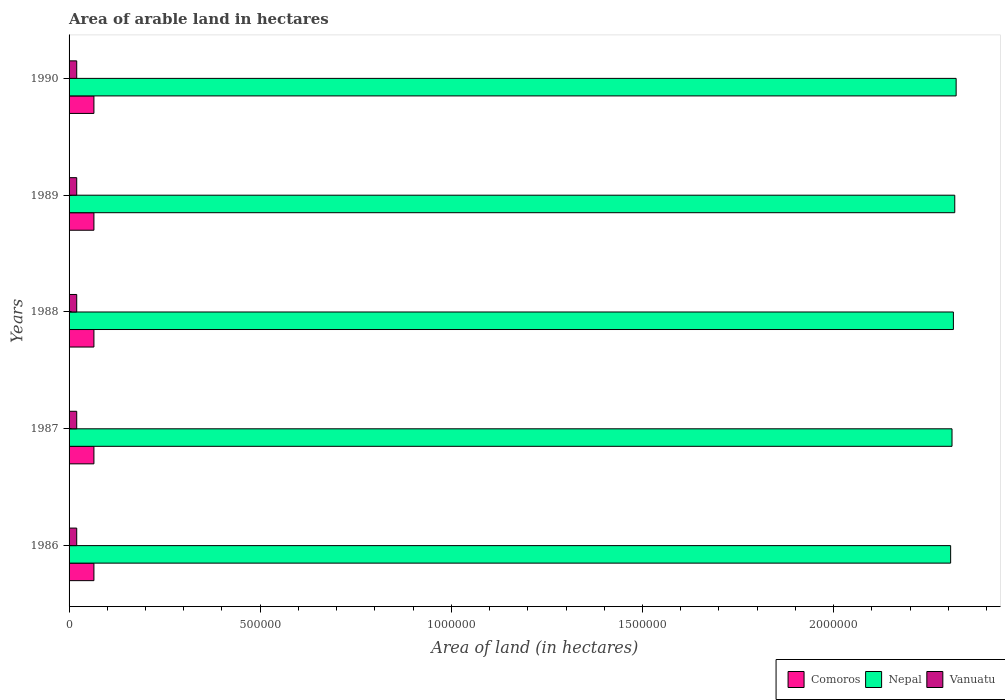How many groups of bars are there?
Your answer should be compact. 5. Are the number of bars per tick equal to the number of legend labels?
Provide a short and direct response. Yes. Are the number of bars on each tick of the Y-axis equal?
Offer a very short reply. Yes. How many bars are there on the 1st tick from the bottom?
Your response must be concise. 3. What is the total arable land in Comoros in 1988?
Your response must be concise. 6.50e+04. Across all years, what is the maximum total arable land in Vanuatu?
Give a very brief answer. 2.00e+04. Across all years, what is the minimum total arable land in Vanuatu?
Provide a succinct answer. 2.00e+04. In which year was the total arable land in Comoros maximum?
Provide a succinct answer. 1986. In which year was the total arable land in Nepal minimum?
Your response must be concise. 1986. What is the total total arable land in Vanuatu in the graph?
Your answer should be very brief. 1.00e+05. What is the difference between the total arable land in Comoros in 1986 and that in 1989?
Offer a very short reply. 0. What is the difference between the total arable land in Nepal in 1987 and the total arable land in Vanuatu in 1988?
Provide a short and direct response. 2.29e+06. What is the average total arable land in Comoros per year?
Keep it short and to the point. 6.50e+04. In the year 1986, what is the difference between the total arable land in Comoros and total arable land in Vanuatu?
Give a very brief answer. 4.50e+04. In how many years, is the total arable land in Nepal greater than 400000 hectares?
Offer a very short reply. 5. What is the ratio of the total arable land in Nepal in 1987 to that in 1989?
Make the answer very short. 1. What is the difference between the highest and the second highest total arable land in Comoros?
Keep it short and to the point. 0. What is the difference between the highest and the lowest total arable land in Nepal?
Provide a short and direct response. 1.44e+04. In how many years, is the total arable land in Vanuatu greater than the average total arable land in Vanuatu taken over all years?
Your response must be concise. 0. What does the 2nd bar from the top in 1990 represents?
Give a very brief answer. Nepal. What does the 2nd bar from the bottom in 1988 represents?
Your response must be concise. Nepal. How many bars are there?
Keep it short and to the point. 15. What is the difference between two consecutive major ticks on the X-axis?
Your answer should be compact. 5.00e+05. Are the values on the major ticks of X-axis written in scientific E-notation?
Your answer should be compact. No. Does the graph contain grids?
Provide a succinct answer. No. Where does the legend appear in the graph?
Make the answer very short. Bottom right. What is the title of the graph?
Your response must be concise. Area of arable land in hectares. Does "United Kingdom" appear as one of the legend labels in the graph?
Ensure brevity in your answer.  No. What is the label or title of the X-axis?
Your answer should be compact. Area of land (in hectares). What is the label or title of the Y-axis?
Make the answer very short. Years. What is the Area of land (in hectares) of Comoros in 1986?
Offer a terse response. 6.50e+04. What is the Area of land (in hectares) of Nepal in 1986?
Your answer should be compact. 2.31e+06. What is the Area of land (in hectares) of Vanuatu in 1986?
Make the answer very short. 2.00e+04. What is the Area of land (in hectares) in Comoros in 1987?
Keep it short and to the point. 6.50e+04. What is the Area of land (in hectares) in Nepal in 1987?
Provide a short and direct response. 2.31e+06. What is the Area of land (in hectares) in Comoros in 1988?
Offer a terse response. 6.50e+04. What is the Area of land (in hectares) in Nepal in 1988?
Your answer should be very brief. 2.31e+06. What is the Area of land (in hectares) in Comoros in 1989?
Provide a succinct answer. 6.50e+04. What is the Area of land (in hectares) of Nepal in 1989?
Your response must be concise. 2.32e+06. What is the Area of land (in hectares) in Vanuatu in 1989?
Your response must be concise. 2.00e+04. What is the Area of land (in hectares) of Comoros in 1990?
Ensure brevity in your answer.  6.50e+04. What is the Area of land (in hectares) in Nepal in 1990?
Your answer should be very brief. 2.32e+06. What is the Area of land (in hectares) of Vanuatu in 1990?
Ensure brevity in your answer.  2.00e+04. Across all years, what is the maximum Area of land (in hectares) of Comoros?
Make the answer very short. 6.50e+04. Across all years, what is the maximum Area of land (in hectares) in Nepal?
Keep it short and to the point. 2.32e+06. Across all years, what is the maximum Area of land (in hectares) of Vanuatu?
Make the answer very short. 2.00e+04. Across all years, what is the minimum Area of land (in hectares) in Comoros?
Keep it short and to the point. 6.50e+04. Across all years, what is the minimum Area of land (in hectares) in Nepal?
Provide a succinct answer. 2.31e+06. What is the total Area of land (in hectares) of Comoros in the graph?
Offer a terse response. 3.25e+05. What is the total Area of land (in hectares) in Nepal in the graph?
Offer a terse response. 1.16e+07. What is the difference between the Area of land (in hectares) in Comoros in 1986 and that in 1987?
Keep it short and to the point. 0. What is the difference between the Area of land (in hectares) in Nepal in 1986 and that in 1987?
Ensure brevity in your answer.  -3600. What is the difference between the Area of land (in hectares) in Nepal in 1986 and that in 1988?
Provide a short and direct response. -7200. What is the difference between the Area of land (in hectares) in Vanuatu in 1986 and that in 1988?
Offer a very short reply. 0. What is the difference between the Area of land (in hectares) of Comoros in 1986 and that in 1989?
Keep it short and to the point. 0. What is the difference between the Area of land (in hectares) in Nepal in 1986 and that in 1989?
Ensure brevity in your answer.  -1.08e+04. What is the difference between the Area of land (in hectares) of Vanuatu in 1986 and that in 1989?
Provide a succinct answer. 0. What is the difference between the Area of land (in hectares) in Nepal in 1986 and that in 1990?
Give a very brief answer. -1.44e+04. What is the difference between the Area of land (in hectares) in Nepal in 1987 and that in 1988?
Ensure brevity in your answer.  -3600. What is the difference between the Area of land (in hectares) of Vanuatu in 1987 and that in 1988?
Your response must be concise. 0. What is the difference between the Area of land (in hectares) in Nepal in 1987 and that in 1989?
Your response must be concise. -7200. What is the difference between the Area of land (in hectares) of Vanuatu in 1987 and that in 1989?
Offer a terse response. 0. What is the difference between the Area of land (in hectares) in Comoros in 1987 and that in 1990?
Provide a succinct answer. 0. What is the difference between the Area of land (in hectares) in Nepal in 1987 and that in 1990?
Offer a terse response. -1.08e+04. What is the difference between the Area of land (in hectares) of Nepal in 1988 and that in 1989?
Your answer should be compact. -3600. What is the difference between the Area of land (in hectares) of Vanuatu in 1988 and that in 1989?
Offer a very short reply. 0. What is the difference between the Area of land (in hectares) in Comoros in 1988 and that in 1990?
Ensure brevity in your answer.  0. What is the difference between the Area of land (in hectares) of Nepal in 1988 and that in 1990?
Ensure brevity in your answer.  -7200. What is the difference between the Area of land (in hectares) in Vanuatu in 1988 and that in 1990?
Keep it short and to the point. 0. What is the difference between the Area of land (in hectares) in Comoros in 1989 and that in 1990?
Your answer should be very brief. 0. What is the difference between the Area of land (in hectares) of Nepal in 1989 and that in 1990?
Make the answer very short. -3600. What is the difference between the Area of land (in hectares) in Vanuatu in 1989 and that in 1990?
Offer a terse response. 0. What is the difference between the Area of land (in hectares) in Comoros in 1986 and the Area of land (in hectares) in Nepal in 1987?
Make the answer very short. -2.24e+06. What is the difference between the Area of land (in hectares) of Comoros in 1986 and the Area of land (in hectares) of Vanuatu in 1987?
Provide a succinct answer. 4.50e+04. What is the difference between the Area of land (in hectares) of Nepal in 1986 and the Area of land (in hectares) of Vanuatu in 1987?
Offer a very short reply. 2.29e+06. What is the difference between the Area of land (in hectares) of Comoros in 1986 and the Area of land (in hectares) of Nepal in 1988?
Your response must be concise. -2.25e+06. What is the difference between the Area of land (in hectares) in Comoros in 1986 and the Area of land (in hectares) in Vanuatu in 1988?
Keep it short and to the point. 4.50e+04. What is the difference between the Area of land (in hectares) of Nepal in 1986 and the Area of land (in hectares) of Vanuatu in 1988?
Make the answer very short. 2.29e+06. What is the difference between the Area of land (in hectares) of Comoros in 1986 and the Area of land (in hectares) of Nepal in 1989?
Your answer should be very brief. -2.25e+06. What is the difference between the Area of land (in hectares) of Comoros in 1986 and the Area of land (in hectares) of Vanuatu in 1989?
Your answer should be very brief. 4.50e+04. What is the difference between the Area of land (in hectares) in Nepal in 1986 and the Area of land (in hectares) in Vanuatu in 1989?
Your answer should be compact. 2.29e+06. What is the difference between the Area of land (in hectares) of Comoros in 1986 and the Area of land (in hectares) of Nepal in 1990?
Offer a terse response. -2.26e+06. What is the difference between the Area of land (in hectares) of Comoros in 1986 and the Area of land (in hectares) of Vanuatu in 1990?
Keep it short and to the point. 4.50e+04. What is the difference between the Area of land (in hectares) of Nepal in 1986 and the Area of land (in hectares) of Vanuatu in 1990?
Give a very brief answer. 2.29e+06. What is the difference between the Area of land (in hectares) in Comoros in 1987 and the Area of land (in hectares) in Nepal in 1988?
Your answer should be very brief. -2.25e+06. What is the difference between the Area of land (in hectares) in Comoros in 1987 and the Area of land (in hectares) in Vanuatu in 1988?
Make the answer very short. 4.50e+04. What is the difference between the Area of land (in hectares) of Nepal in 1987 and the Area of land (in hectares) of Vanuatu in 1988?
Your answer should be very brief. 2.29e+06. What is the difference between the Area of land (in hectares) of Comoros in 1987 and the Area of land (in hectares) of Nepal in 1989?
Offer a terse response. -2.25e+06. What is the difference between the Area of land (in hectares) of Comoros in 1987 and the Area of land (in hectares) of Vanuatu in 1989?
Your answer should be compact. 4.50e+04. What is the difference between the Area of land (in hectares) in Nepal in 1987 and the Area of land (in hectares) in Vanuatu in 1989?
Keep it short and to the point. 2.29e+06. What is the difference between the Area of land (in hectares) in Comoros in 1987 and the Area of land (in hectares) in Nepal in 1990?
Offer a terse response. -2.26e+06. What is the difference between the Area of land (in hectares) of Comoros in 1987 and the Area of land (in hectares) of Vanuatu in 1990?
Give a very brief answer. 4.50e+04. What is the difference between the Area of land (in hectares) in Nepal in 1987 and the Area of land (in hectares) in Vanuatu in 1990?
Your response must be concise. 2.29e+06. What is the difference between the Area of land (in hectares) in Comoros in 1988 and the Area of land (in hectares) in Nepal in 1989?
Your answer should be compact. -2.25e+06. What is the difference between the Area of land (in hectares) of Comoros in 1988 and the Area of land (in hectares) of Vanuatu in 1989?
Your answer should be very brief. 4.50e+04. What is the difference between the Area of land (in hectares) of Nepal in 1988 and the Area of land (in hectares) of Vanuatu in 1989?
Your answer should be compact. 2.29e+06. What is the difference between the Area of land (in hectares) in Comoros in 1988 and the Area of land (in hectares) in Nepal in 1990?
Give a very brief answer. -2.26e+06. What is the difference between the Area of land (in hectares) in Comoros in 1988 and the Area of land (in hectares) in Vanuatu in 1990?
Keep it short and to the point. 4.50e+04. What is the difference between the Area of land (in hectares) in Nepal in 1988 and the Area of land (in hectares) in Vanuatu in 1990?
Offer a terse response. 2.29e+06. What is the difference between the Area of land (in hectares) in Comoros in 1989 and the Area of land (in hectares) in Nepal in 1990?
Make the answer very short. -2.26e+06. What is the difference between the Area of land (in hectares) of Comoros in 1989 and the Area of land (in hectares) of Vanuatu in 1990?
Provide a succinct answer. 4.50e+04. What is the difference between the Area of land (in hectares) of Nepal in 1989 and the Area of land (in hectares) of Vanuatu in 1990?
Make the answer very short. 2.30e+06. What is the average Area of land (in hectares) in Comoros per year?
Provide a short and direct response. 6.50e+04. What is the average Area of land (in hectares) in Nepal per year?
Your answer should be compact. 2.31e+06. What is the average Area of land (in hectares) of Vanuatu per year?
Keep it short and to the point. 2.00e+04. In the year 1986, what is the difference between the Area of land (in hectares) in Comoros and Area of land (in hectares) in Nepal?
Ensure brevity in your answer.  -2.24e+06. In the year 1986, what is the difference between the Area of land (in hectares) of Comoros and Area of land (in hectares) of Vanuatu?
Your response must be concise. 4.50e+04. In the year 1986, what is the difference between the Area of land (in hectares) in Nepal and Area of land (in hectares) in Vanuatu?
Your answer should be very brief. 2.29e+06. In the year 1987, what is the difference between the Area of land (in hectares) in Comoros and Area of land (in hectares) in Nepal?
Your answer should be very brief. -2.24e+06. In the year 1987, what is the difference between the Area of land (in hectares) in Comoros and Area of land (in hectares) in Vanuatu?
Ensure brevity in your answer.  4.50e+04. In the year 1987, what is the difference between the Area of land (in hectares) of Nepal and Area of land (in hectares) of Vanuatu?
Make the answer very short. 2.29e+06. In the year 1988, what is the difference between the Area of land (in hectares) of Comoros and Area of land (in hectares) of Nepal?
Provide a short and direct response. -2.25e+06. In the year 1988, what is the difference between the Area of land (in hectares) in Comoros and Area of land (in hectares) in Vanuatu?
Offer a very short reply. 4.50e+04. In the year 1988, what is the difference between the Area of land (in hectares) in Nepal and Area of land (in hectares) in Vanuatu?
Provide a succinct answer. 2.29e+06. In the year 1989, what is the difference between the Area of land (in hectares) in Comoros and Area of land (in hectares) in Nepal?
Provide a succinct answer. -2.25e+06. In the year 1989, what is the difference between the Area of land (in hectares) of Comoros and Area of land (in hectares) of Vanuatu?
Offer a terse response. 4.50e+04. In the year 1989, what is the difference between the Area of land (in hectares) of Nepal and Area of land (in hectares) of Vanuatu?
Your answer should be very brief. 2.30e+06. In the year 1990, what is the difference between the Area of land (in hectares) in Comoros and Area of land (in hectares) in Nepal?
Offer a terse response. -2.26e+06. In the year 1990, what is the difference between the Area of land (in hectares) in Comoros and Area of land (in hectares) in Vanuatu?
Your answer should be very brief. 4.50e+04. In the year 1990, what is the difference between the Area of land (in hectares) in Nepal and Area of land (in hectares) in Vanuatu?
Your answer should be very brief. 2.30e+06. What is the ratio of the Area of land (in hectares) in Comoros in 1986 to that in 1987?
Your answer should be very brief. 1. What is the ratio of the Area of land (in hectares) of Nepal in 1986 to that in 1987?
Provide a short and direct response. 1. What is the ratio of the Area of land (in hectares) of Comoros in 1986 to that in 1988?
Provide a short and direct response. 1. What is the ratio of the Area of land (in hectares) in Nepal in 1986 to that in 1988?
Your answer should be very brief. 1. What is the ratio of the Area of land (in hectares) in Comoros in 1986 to that in 1990?
Your answer should be very brief. 1. What is the ratio of the Area of land (in hectares) in Nepal in 1986 to that in 1990?
Provide a short and direct response. 0.99. What is the ratio of the Area of land (in hectares) of Comoros in 1987 to that in 1988?
Give a very brief answer. 1. What is the ratio of the Area of land (in hectares) of Vanuatu in 1987 to that in 1988?
Keep it short and to the point. 1. What is the ratio of the Area of land (in hectares) in Vanuatu in 1987 to that in 1989?
Ensure brevity in your answer.  1. What is the ratio of the Area of land (in hectares) in Comoros in 1987 to that in 1990?
Ensure brevity in your answer.  1. What is the ratio of the Area of land (in hectares) of Comoros in 1988 to that in 1989?
Offer a very short reply. 1. What is the ratio of the Area of land (in hectares) of Nepal in 1988 to that in 1989?
Your answer should be very brief. 1. What is the ratio of the Area of land (in hectares) in Nepal in 1988 to that in 1990?
Make the answer very short. 1. What is the ratio of the Area of land (in hectares) of Vanuatu in 1988 to that in 1990?
Provide a succinct answer. 1. What is the ratio of the Area of land (in hectares) of Comoros in 1989 to that in 1990?
Ensure brevity in your answer.  1. What is the ratio of the Area of land (in hectares) of Nepal in 1989 to that in 1990?
Ensure brevity in your answer.  1. What is the ratio of the Area of land (in hectares) in Vanuatu in 1989 to that in 1990?
Ensure brevity in your answer.  1. What is the difference between the highest and the second highest Area of land (in hectares) of Nepal?
Keep it short and to the point. 3600. What is the difference between the highest and the lowest Area of land (in hectares) of Comoros?
Keep it short and to the point. 0. What is the difference between the highest and the lowest Area of land (in hectares) of Nepal?
Offer a terse response. 1.44e+04. 